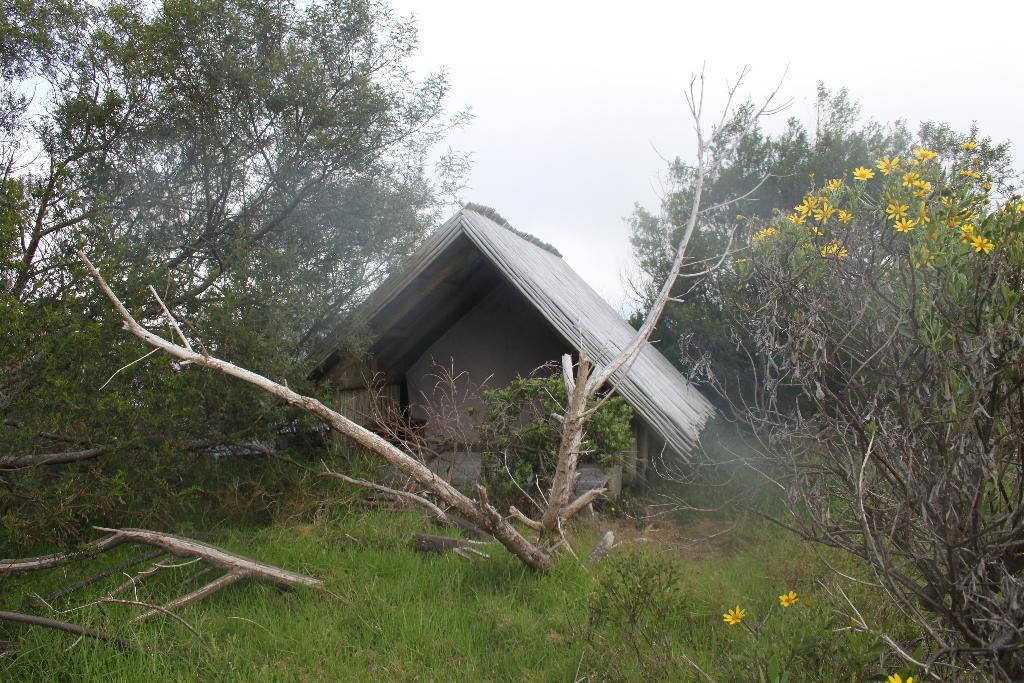What type of structure is present in the image? There is a shed in the image. What type of vegetation can be seen in the image? There is grass, trees, and flowers in the image. What type of ticket is required to enter the shed in the image? There is no mention of a ticket or any requirement to enter the shed in the image. 